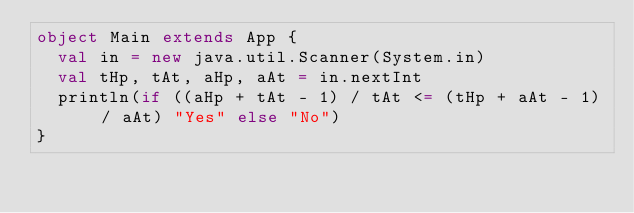<code> <loc_0><loc_0><loc_500><loc_500><_Scala_>object Main extends App {
  val in = new java.util.Scanner(System.in)
  val tHp, tAt, aHp, aAt = in.nextInt
  println(if ((aHp + tAt - 1) / tAt <= (tHp + aAt - 1) / aAt) "Yes" else "No")
}</code> 